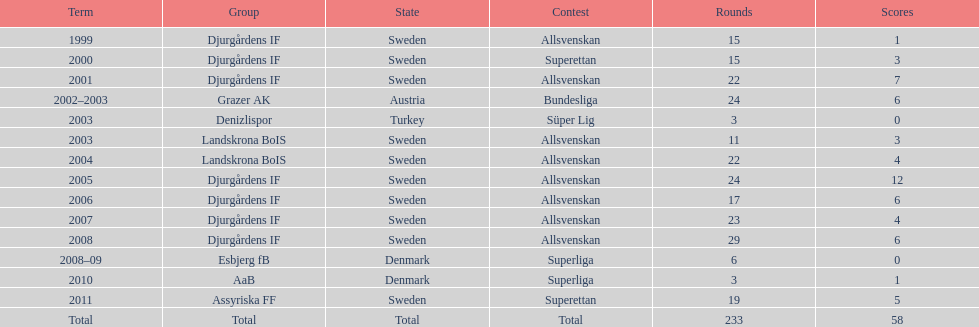What season has the most goals? 2005. 